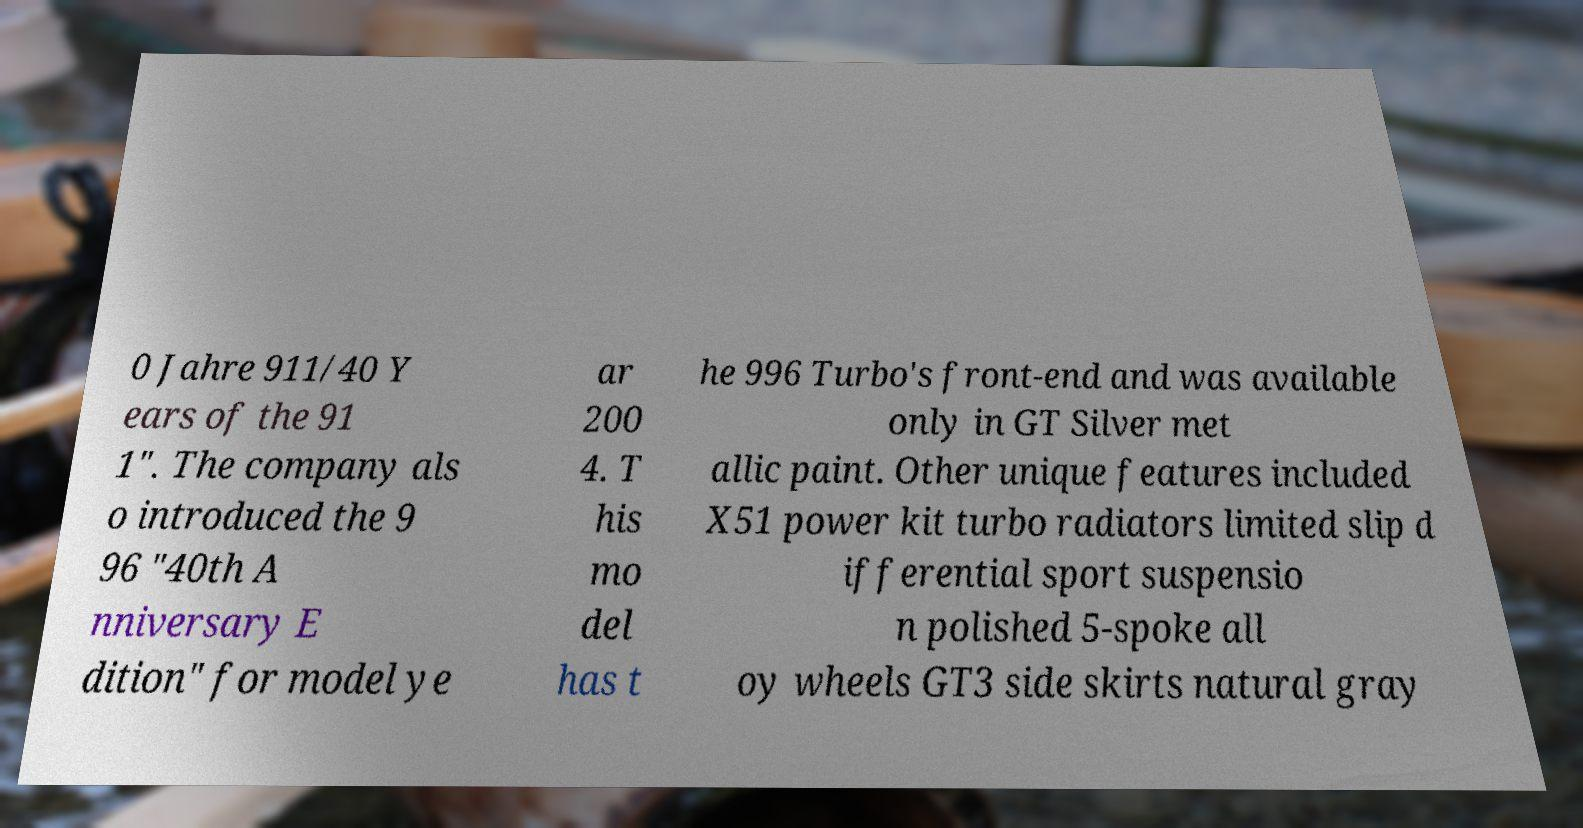Could you extract and type out the text from this image? 0 Jahre 911/40 Y ears of the 91 1". The company als o introduced the 9 96 "40th A nniversary E dition" for model ye ar 200 4. T his mo del has t he 996 Turbo's front-end and was available only in GT Silver met allic paint. Other unique features included X51 power kit turbo radiators limited slip d ifferential sport suspensio n polished 5-spoke all oy wheels GT3 side skirts natural gray 